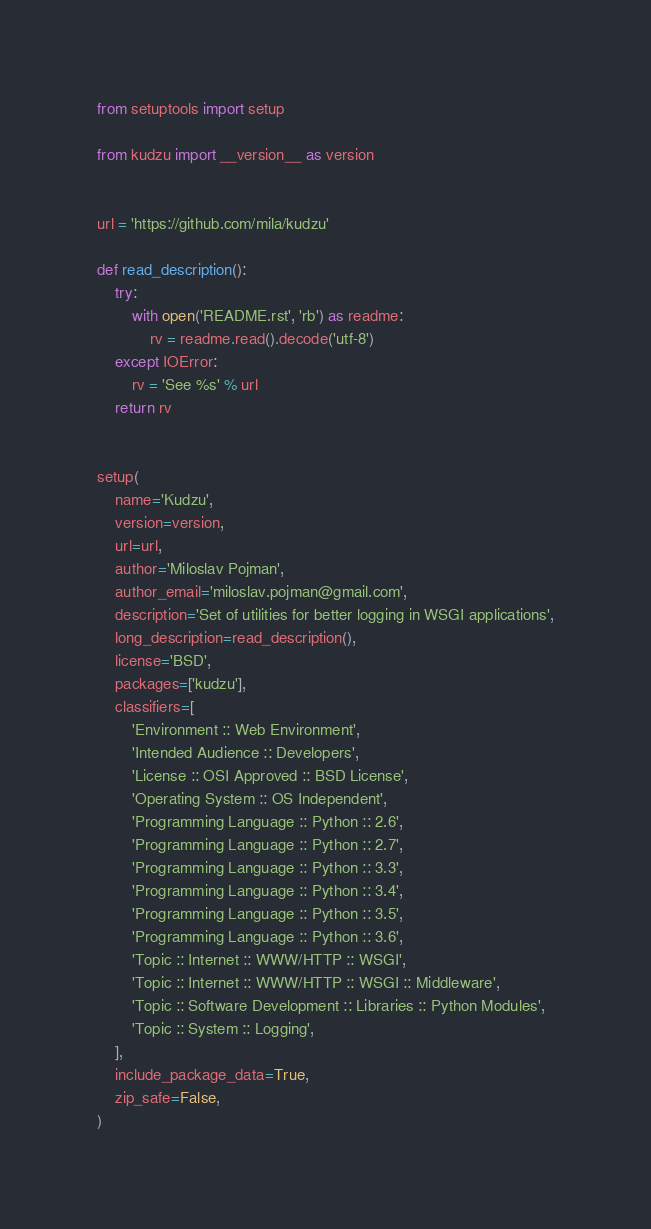<code> <loc_0><loc_0><loc_500><loc_500><_Python_>
from setuptools import setup

from kudzu import __version__ as version


url = 'https://github.com/mila/kudzu'

def read_description():
    try:
        with open('README.rst', 'rb') as readme:
            rv = readme.read().decode('utf-8')
    except IOError:
        rv = 'See %s' % url
    return rv


setup(
    name='Kudzu',
    version=version,
    url=url,
    author='Miloslav Pojman',
    author_email='miloslav.pojman@gmail.com',
    description='Set of utilities for better logging in WSGI applications',
    long_description=read_description(),
    license='BSD',
    packages=['kudzu'],
    classifiers=[
        'Environment :: Web Environment',
        'Intended Audience :: Developers',
        'License :: OSI Approved :: BSD License',
        'Operating System :: OS Independent',
        'Programming Language :: Python :: 2.6',
        'Programming Language :: Python :: 2.7',
        'Programming Language :: Python :: 3.3',
        'Programming Language :: Python :: 3.4',
        'Programming Language :: Python :: 3.5',
        'Programming Language :: Python :: 3.6',
        'Topic :: Internet :: WWW/HTTP :: WSGI',
        'Topic :: Internet :: WWW/HTTP :: WSGI :: Middleware',
        'Topic :: Software Development :: Libraries :: Python Modules',
        'Topic :: System :: Logging',
    ],
    include_package_data=True,
    zip_safe=False,
)
</code> 